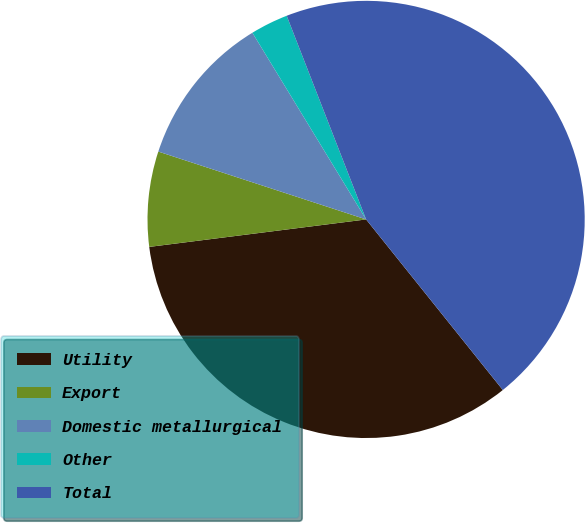Convert chart. <chart><loc_0><loc_0><loc_500><loc_500><pie_chart><fcel>Utility<fcel>Export<fcel>Domestic metallurgical<fcel>Other<fcel>Total<nl><fcel>33.75%<fcel>7.03%<fcel>11.27%<fcel>2.79%<fcel>45.17%<nl></chart> 